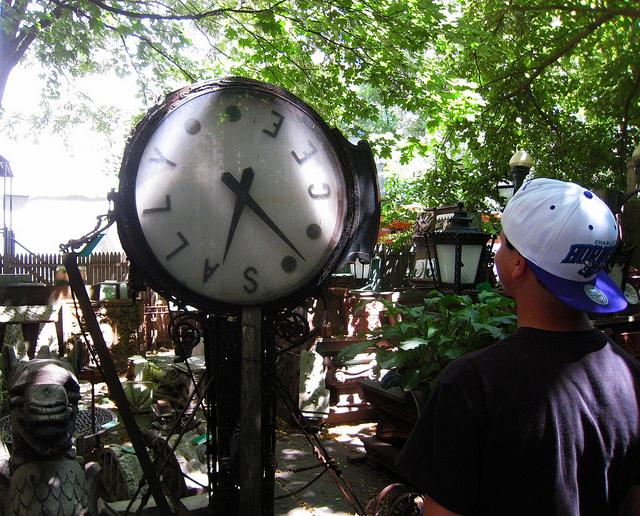What team is on this guy's hat?
Answer briefly. Hornets. What girls name is in the clock?
Keep it brief. Sally. What time is it?
Give a very brief answer. 6:23. 